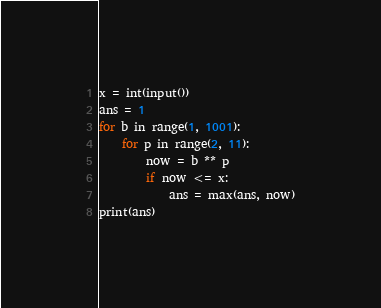Convert code to text. <code><loc_0><loc_0><loc_500><loc_500><_Python_>x = int(input())
ans = 1
for b in range(1, 1001):
    for p in range(2, 11):
        now = b ** p
        if now <= x:
            ans = max(ans, now)
print(ans)</code> 